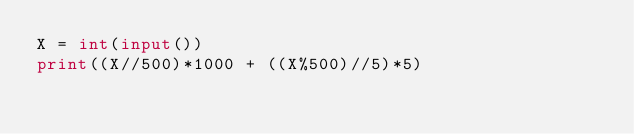<code> <loc_0><loc_0><loc_500><loc_500><_Python_>X = int(input())
print((X//500)*1000 + ((X%500)//5)*5)</code> 